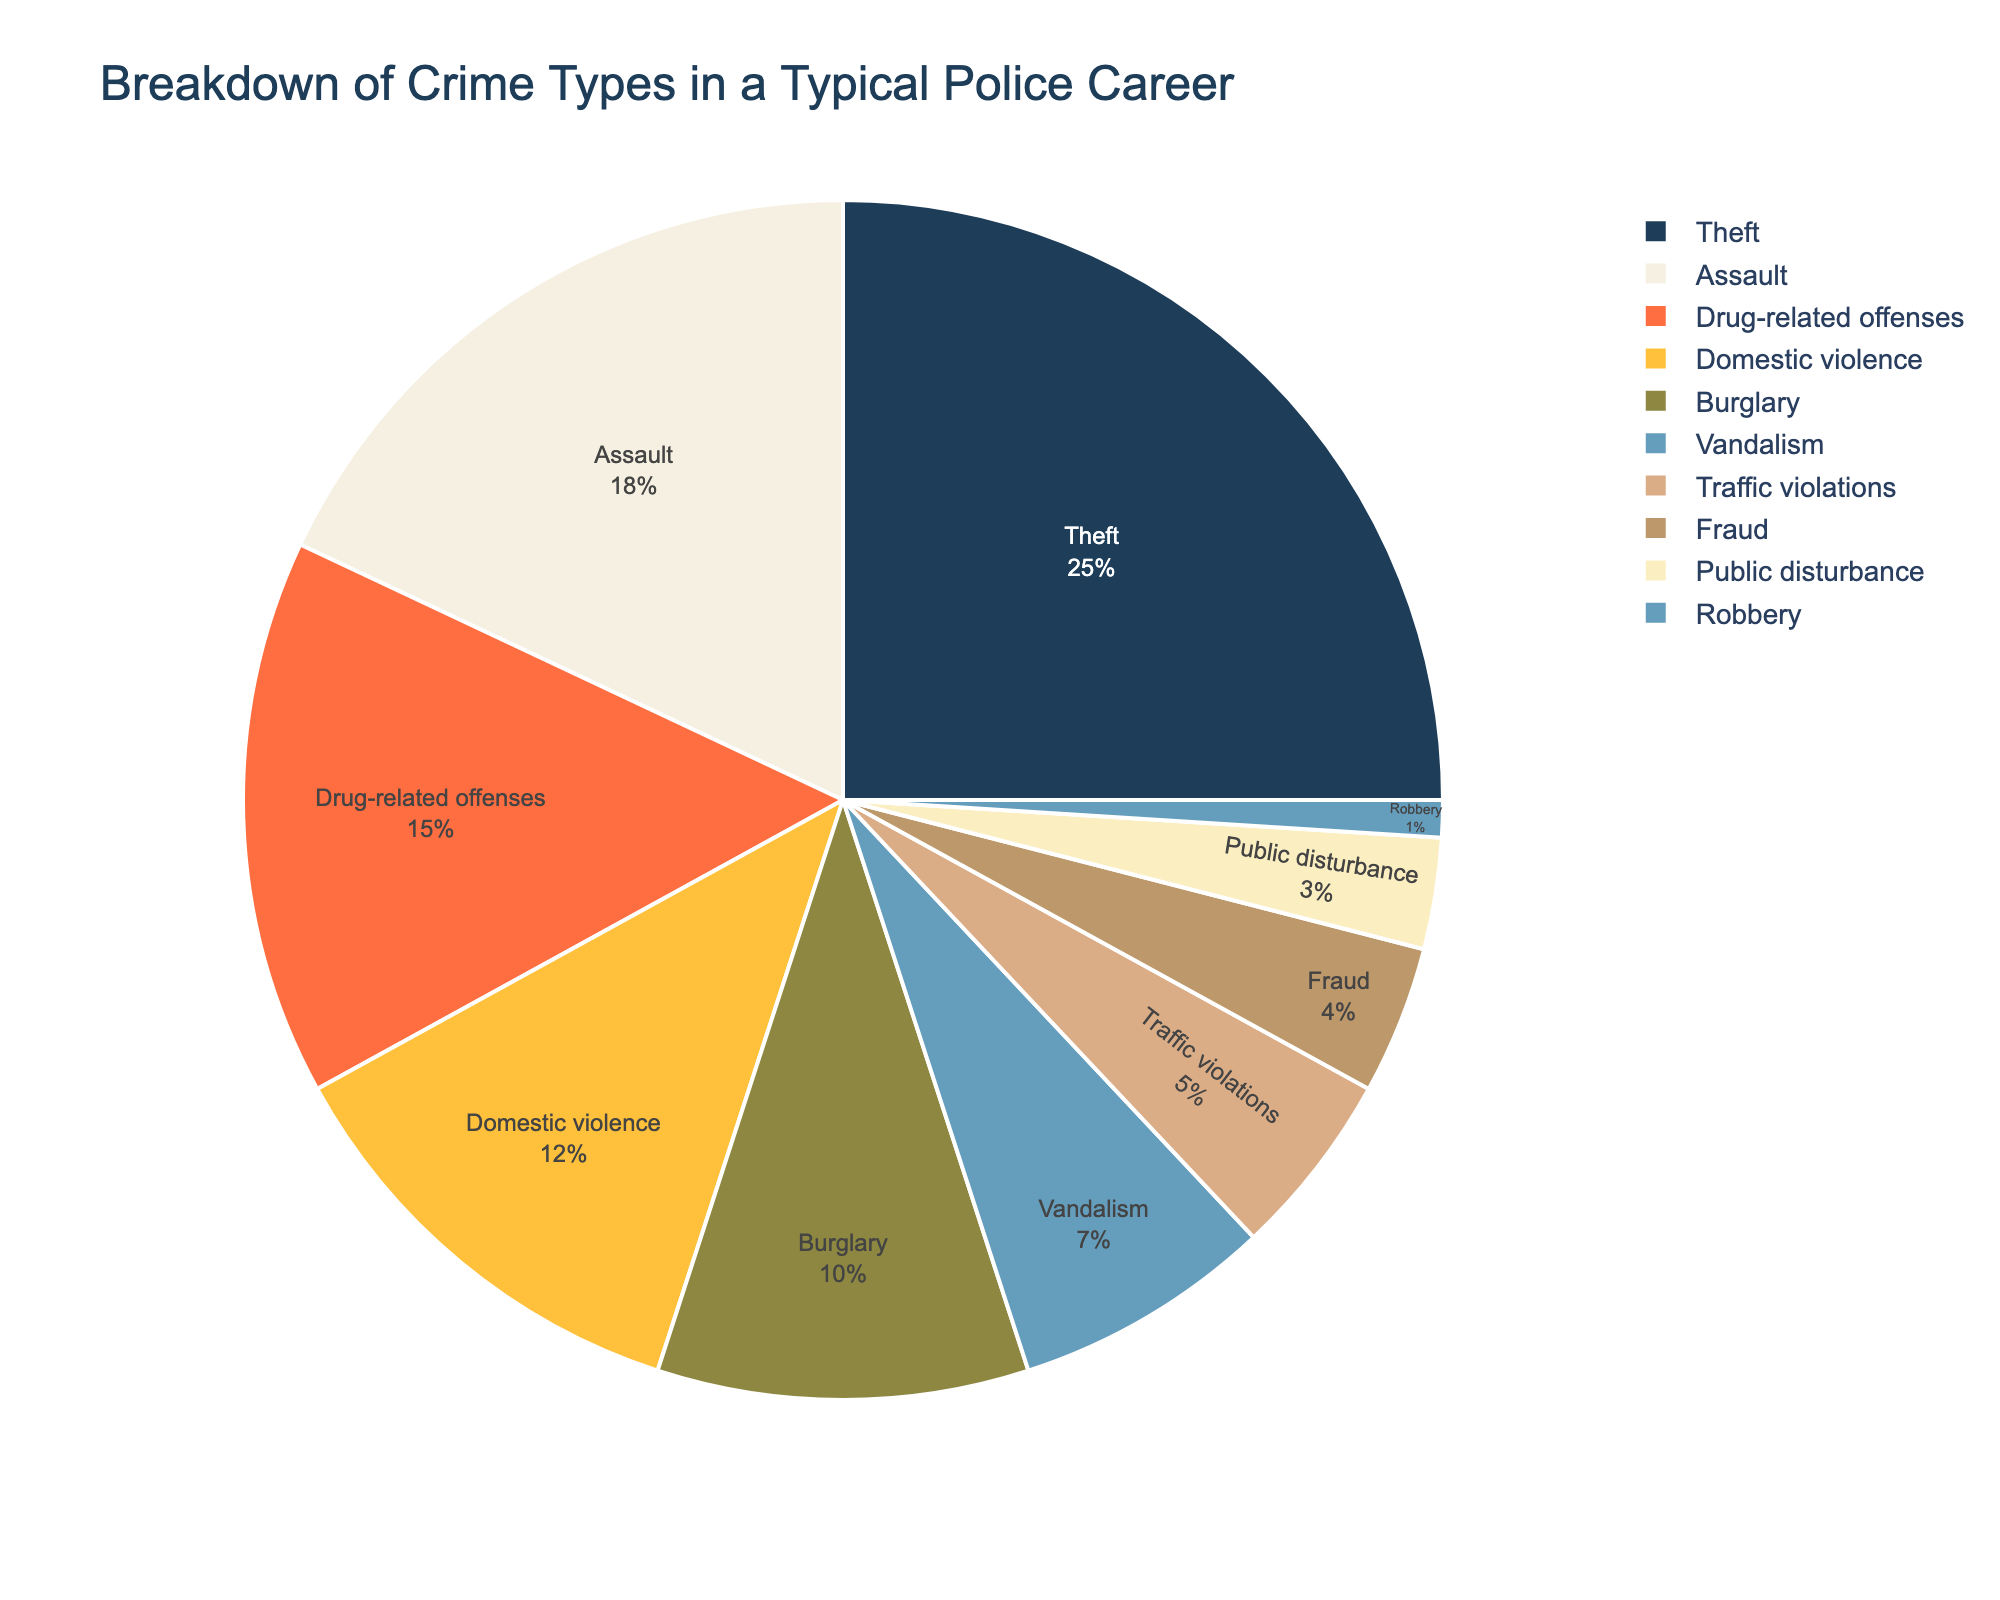What is the most common type of crime encountered? The largest portion of the pie chart represents the most common type of crime. Theft has the largest percentage at 25%.
Answer: Theft Which crime type is least common? The smallest section of the pie chart represents the least common type of crime. Robbery has the smallest percentage at 1%.
Answer: Robbery How much more frequent are Assaults compared to Traffic violations? Find the percentage for Assault (18%) and for Traffic violations (5%), then subtract the two. 18% - 5% = 13%.
Answer: 13% What is the combined percentage of Theft and Assault? Add the percentages for Theft (25%) and Assault (18%). 25% + 18% = 43%.
Answer: 43% Which crime types combined make up exactly half (50%) of the chart? Sum the percentages of the crime types until reaching 50%. Theft (25%), plus Assault (18%) gives 43%, and adding Drug-related offenses (15%) gives 58%, which is over 50%. So, Theft (25%) and Assault (18%), plus partial Drug-related offenses (7%) until 25+18+7 = 50%.
Answer: Theft, Assault, and part of Drug-related offenses Is the percentage of Burglary higher or lower than Domestic violence? Compare the percentage of Burglary (10%) to Domestic violence (12%). 10% < 12%.
Answer: Lower What is the total percentage for minor crimes like Vandalism, Traffic violations, and Public disturbance? Add the percentages for Vandalism (7%), Traffic violations (5%), and Public disturbance (3%). 7% + 5% + 3% = 15%.
Answer: 15% Which type of crime has a similar percentage as Vandalism when combined with Public disturbance? Compare the sum of Vandalism (7%) and Public disturbance (3%) which is 10%, to the percentage of Burglary (10%).
Answer: Burglary What color represents Drug-related offenses in the chart? Identify the segment labeled "Drug-related offenses" and describe the color.
Answer: Orange Of the lesser common crimes listed (Fraud, Public disturbance, Robbery), which one has the second smallest percentage? List the percentages for Fraud (4%), Public disturbance (3%), and Robbery (1%) and find the second smallest.
Answer: Public disturbance 